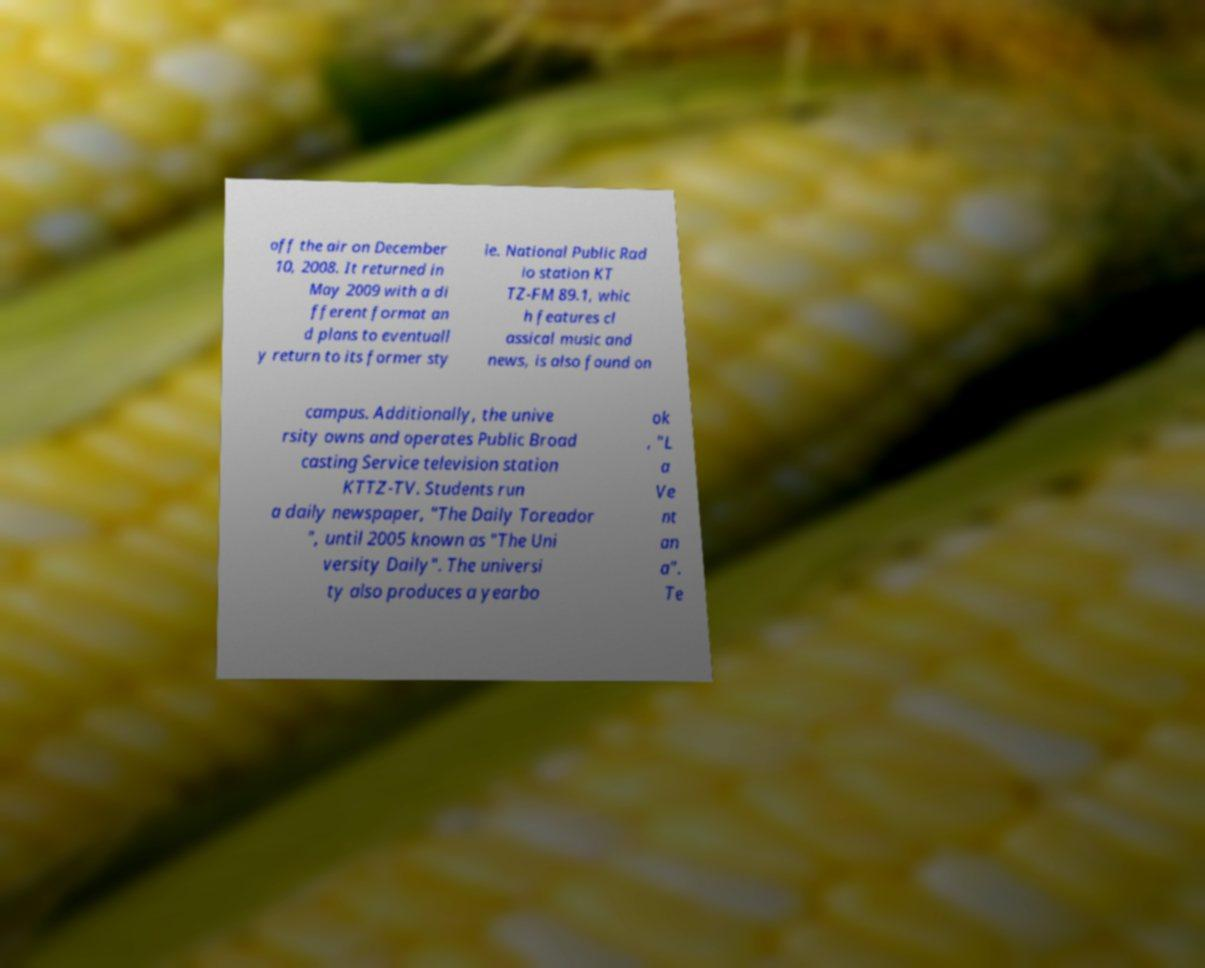Can you read and provide the text displayed in the image?This photo seems to have some interesting text. Can you extract and type it out for me? off the air on December 10, 2008. It returned in May 2009 with a di fferent format an d plans to eventuall y return to its former sty le. National Public Rad io station KT TZ-FM 89.1, whic h features cl assical music and news, is also found on campus. Additionally, the unive rsity owns and operates Public Broad casting Service television station KTTZ-TV. Students run a daily newspaper, "The Daily Toreador ", until 2005 known as "The Uni versity Daily". The universi ty also produces a yearbo ok , "L a Ve nt an a". Te 